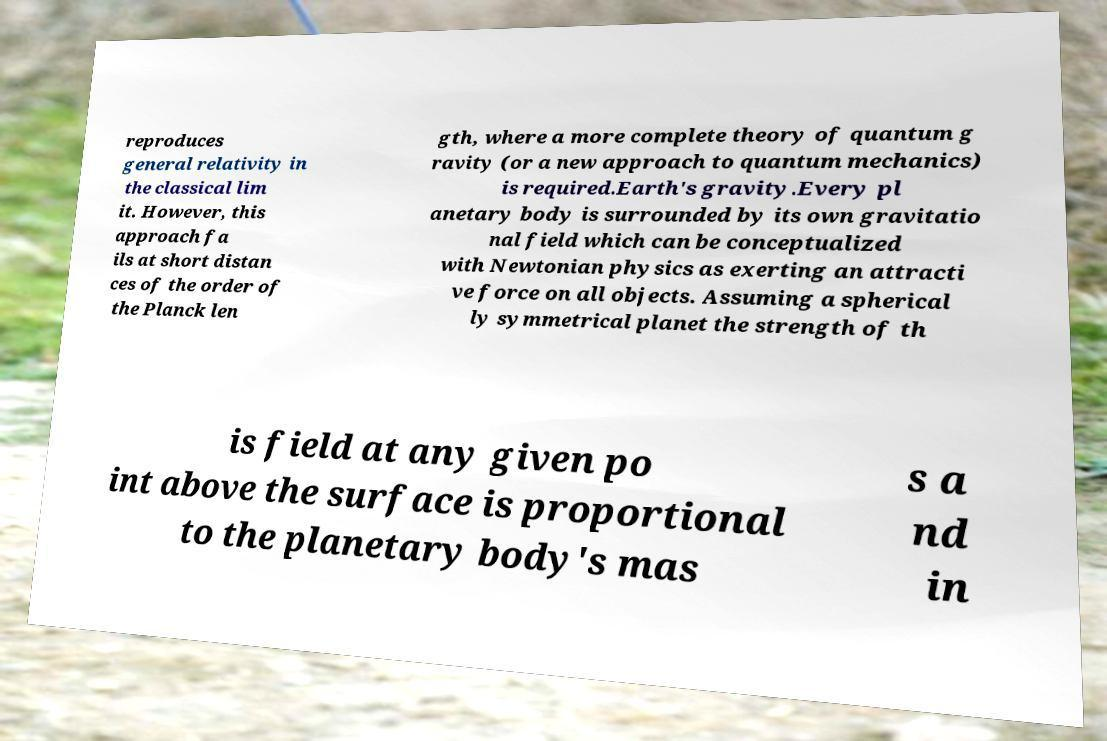Could you extract and type out the text from this image? reproduces general relativity in the classical lim it. However, this approach fa ils at short distan ces of the order of the Planck len gth, where a more complete theory of quantum g ravity (or a new approach to quantum mechanics) is required.Earth's gravity.Every pl anetary body is surrounded by its own gravitatio nal field which can be conceptualized with Newtonian physics as exerting an attracti ve force on all objects. Assuming a spherical ly symmetrical planet the strength of th is field at any given po int above the surface is proportional to the planetary body's mas s a nd in 